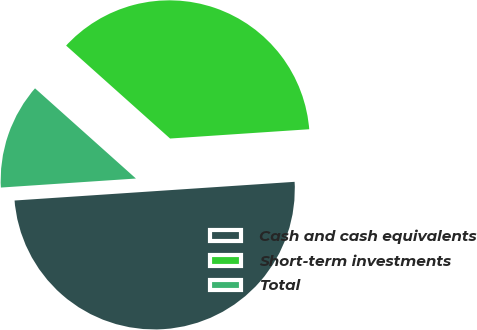Convert chart. <chart><loc_0><loc_0><loc_500><loc_500><pie_chart><fcel>Cash and cash equivalents<fcel>Short-term investments<fcel>Total<nl><fcel>50.0%<fcel>37.33%<fcel>12.67%<nl></chart> 